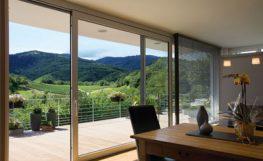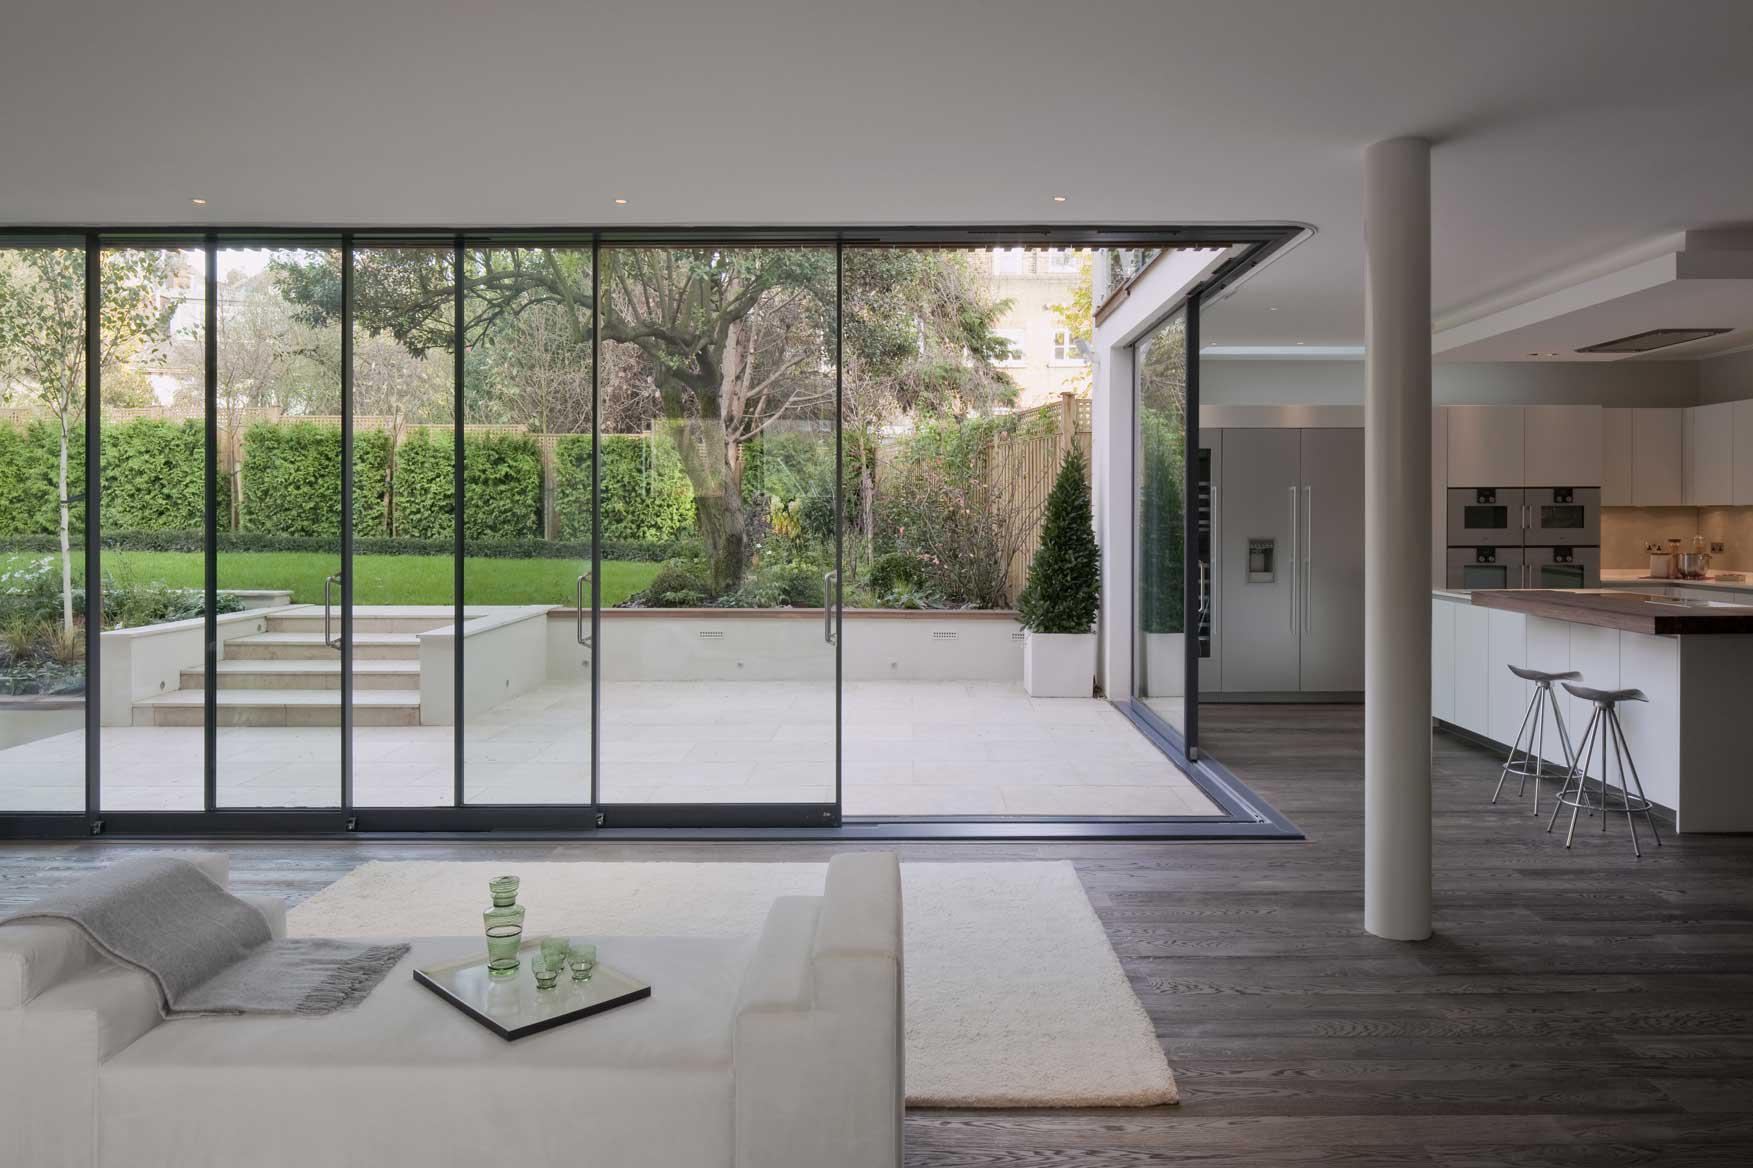The first image is the image on the left, the second image is the image on the right. Examine the images to the left and right. Is the description "The doors are open in both images." accurate? Answer yes or no. Yes. 